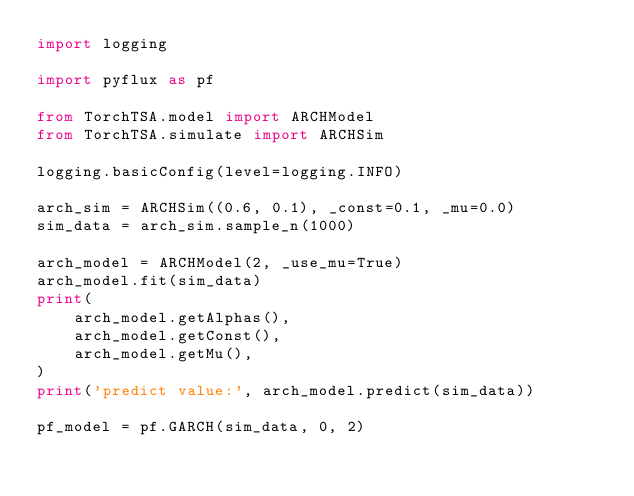<code> <loc_0><loc_0><loc_500><loc_500><_Python_>import logging

import pyflux as pf

from TorchTSA.model import ARCHModel
from TorchTSA.simulate import ARCHSim

logging.basicConfig(level=logging.INFO)

arch_sim = ARCHSim((0.6, 0.1), _const=0.1, _mu=0.0)
sim_data = arch_sim.sample_n(1000)

arch_model = ARCHModel(2, _use_mu=True)
arch_model.fit(sim_data)
print(
    arch_model.getAlphas(),
    arch_model.getConst(),
    arch_model.getMu(),
)
print('predict value:', arch_model.predict(sim_data))

pf_model = pf.GARCH(sim_data, 0, 2)</code> 